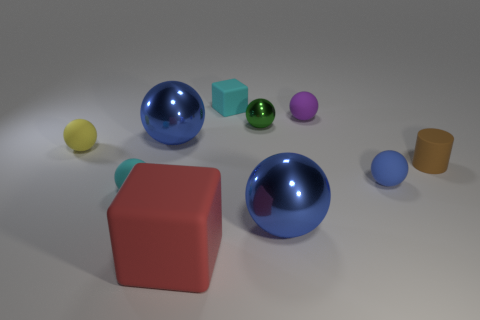There is a small rubber ball that is both left of the purple sphere and right of the tiny yellow rubber thing; what color is it?
Give a very brief answer. Cyan. Are there any matte things in front of the small cyan block?
Ensure brevity in your answer.  Yes. How many metallic things are in front of the big blue metal thing that is in front of the yellow sphere?
Your response must be concise. 0. There is a cyan sphere that is made of the same material as the yellow sphere; what is its size?
Keep it short and to the point. Small. The red cube has what size?
Your answer should be compact. Large. Does the small brown thing have the same material as the small yellow object?
Your response must be concise. Yes. How many spheres are cyan things or big things?
Keep it short and to the point. 3. What is the color of the metallic thing in front of the big blue object behind the small matte cylinder?
Your answer should be very brief. Blue. How many green objects are behind the big metallic object that is on the left side of the metallic thing right of the small green metallic thing?
Your answer should be very brief. 1. Is the shape of the tiny cyan object that is on the left side of the cyan cube the same as the brown rubber object that is to the right of the small cyan matte cube?
Make the answer very short. No. 